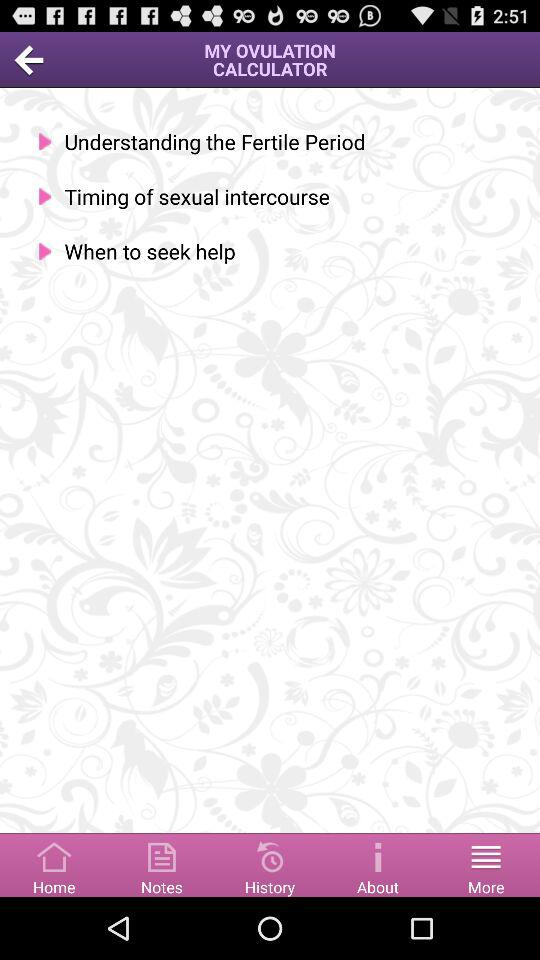Which tab am I using? You are using "More" tab. 